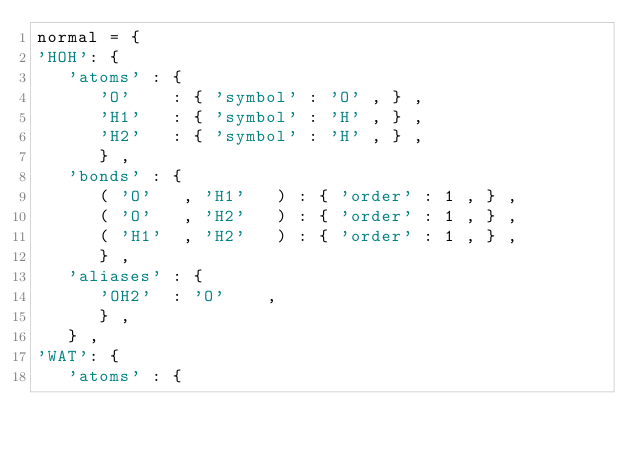Convert code to text. <code><loc_0><loc_0><loc_500><loc_500><_Python_>normal = {
'HOH': {
   'atoms' : {
      'O'    : { 'symbol' : 'O' , } ,
      'H1'   : { 'symbol' : 'H' , } ,
      'H2'   : { 'symbol' : 'H' , } ,
      } ,
   'bonds' : {
      ( 'O'   , 'H1'   ) : { 'order' : 1 , } ,
      ( 'O'   , 'H2'   ) : { 'order' : 1 , } ,
      ( 'H1'  , 'H2'   ) : { 'order' : 1 , } ,
      } ,
   'aliases' : {
      'OH2'  : 'O'    ,
      } ,
   } ,
'WAT': {
   'atoms' : {</code> 